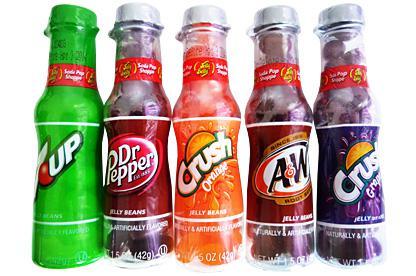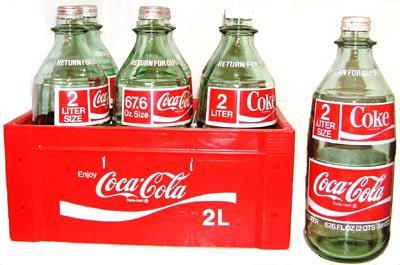The first image is the image on the left, the second image is the image on the right. Analyze the images presented: Is the assertion "The left image includes at least three metallic-looking, multicolored bottles with red caps in a row, with the middle bottle slightly forward." valid? Answer yes or no. No. The first image is the image on the left, the second image is the image on the right. Evaluate the accuracy of this statement regarding the images: "In one of the images, all of the bottles are Coca-Cola bottles.". Is it true? Answer yes or no. Yes. 